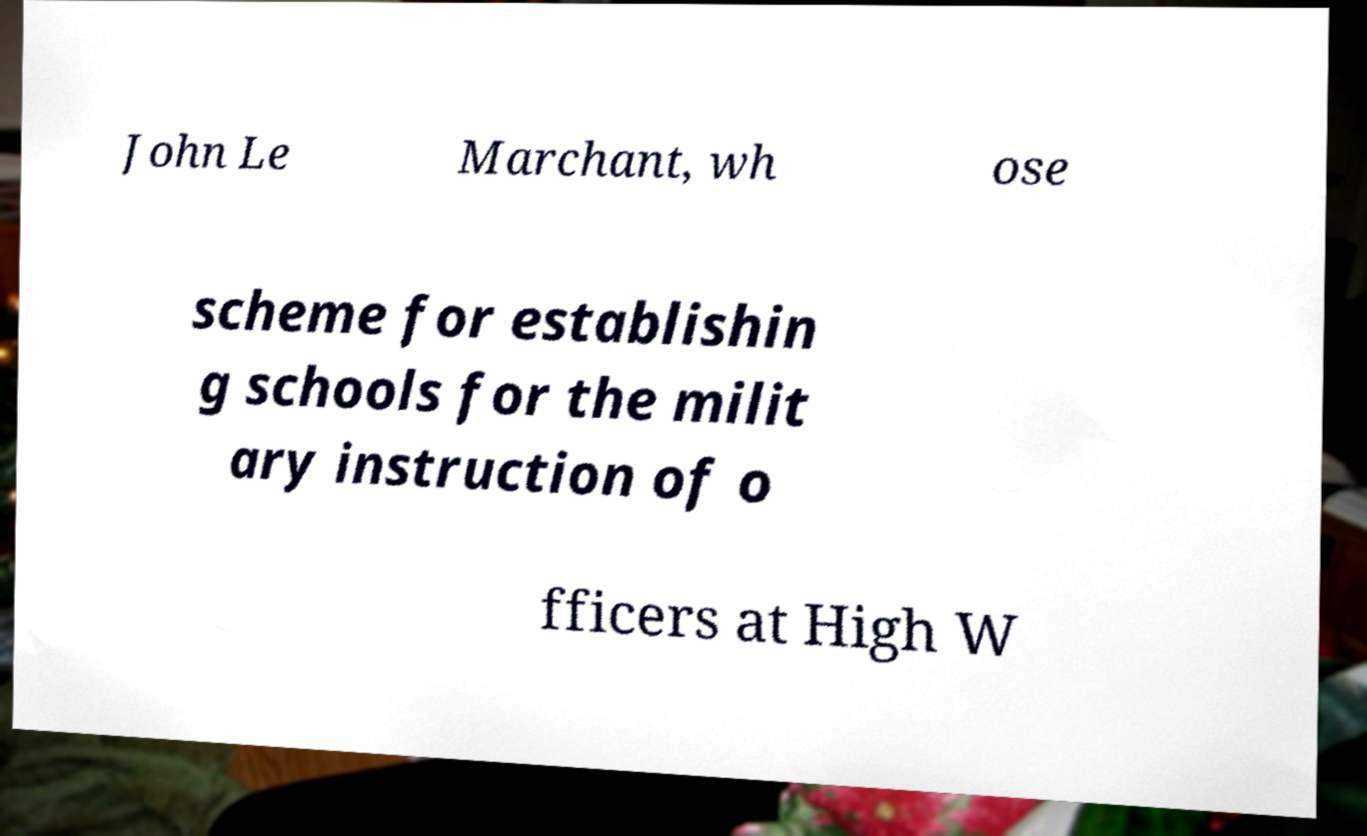Could you extract and type out the text from this image? John Le Marchant, wh ose scheme for establishin g schools for the milit ary instruction of o fficers at High W 